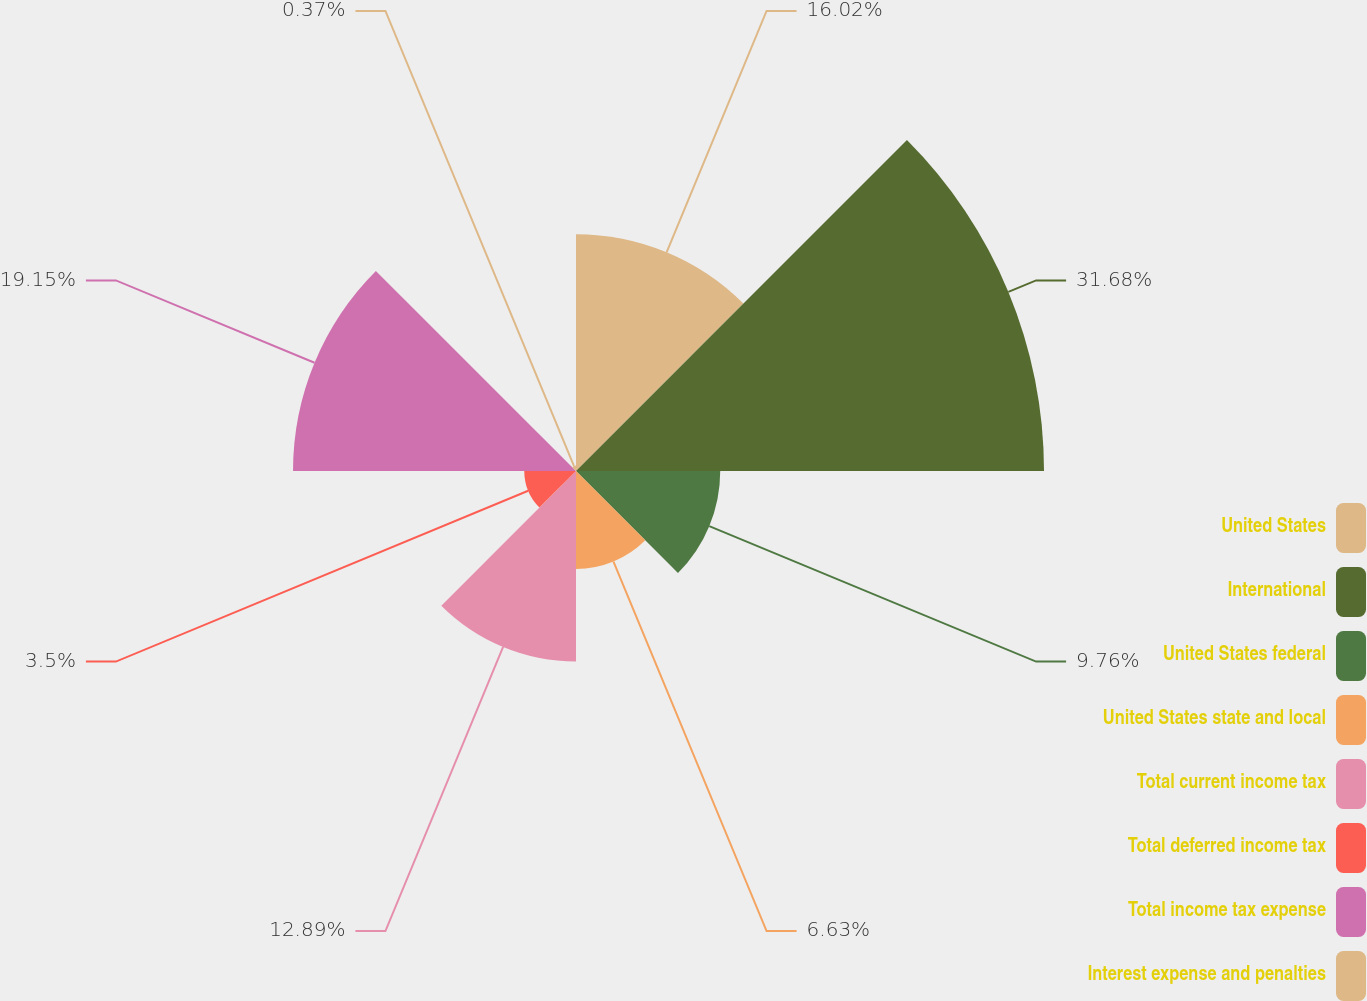Convert chart to OTSL. <chart><loc_0><loc_0><loc_500><loc_500><pie_chart><fcel>United States<fcel>International<fcel>United States federal<fcel>United States state and local<fcel>Total current income tax<fcel>Total deferred income tax<fcel>Total income tax expense<fcel>Interest expense and penalties<nl><fcel>16.02%<fcel>31.67%<fcel>9.76%<fcel>6.63%<fcel>12.89%<fcel>3.5%<fcel>19.15%<fcel>0.37%<nl></chart> 